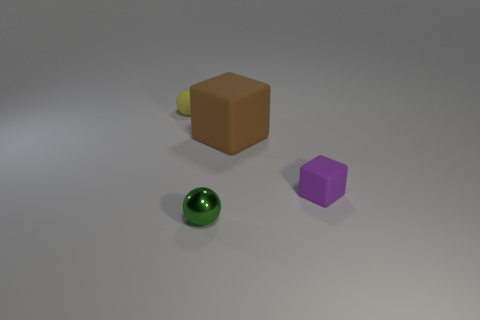Does the purple rubber cube in front of the rubber ball have the same size as the brown rubber block?
Your response must be concise. No. What is the material of the tiny object that is to the right of the ball that is right of the sphere to the left of the metallic object?
Give a very brief answer. Rubber. Is the color of the ball that is behind the brown block the same as the thing to the right of the big brown rubber cube?
Your answer should be very brief. No. What material is the small ball in front of the matte ball left of the green sphere?
Make the answer very short. Metal. What color is the sphere that is the same size as the metallic object?
Give a very brief answer. Yellow. There is a purple rubber thing; is it the same shape as the object that is behind the brown object?
Ensure brevity in your answer.  No. What number of small yellow balls are on the left side of the tiny ball that is left of the small sphere in front of the large brown rubber thing?
Your answer should be compact. 0. There is a sphere right of the tiny rubber object on the left side of the small block; what is its size?
Keep it short and to the point. Small. There is a yellow ball that is the same material as the purple thing; what size is it?
Offer a terse response. Small. What is the shape of the thing that is right of the green ball and to the left of the small purple cube?
Offer a very short reply. Cube. 